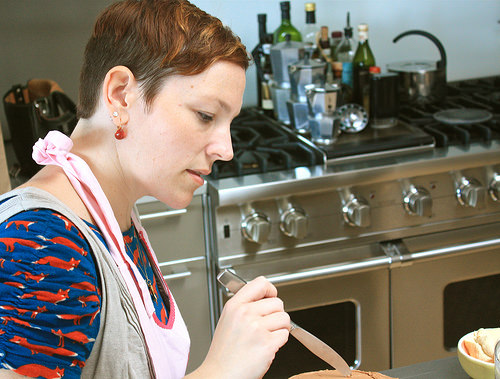<image>
Is there a woman in front of the kitchen? Yes. The woman is positioned in front of the kitchen, appearing closer to the camera viewpoint. 